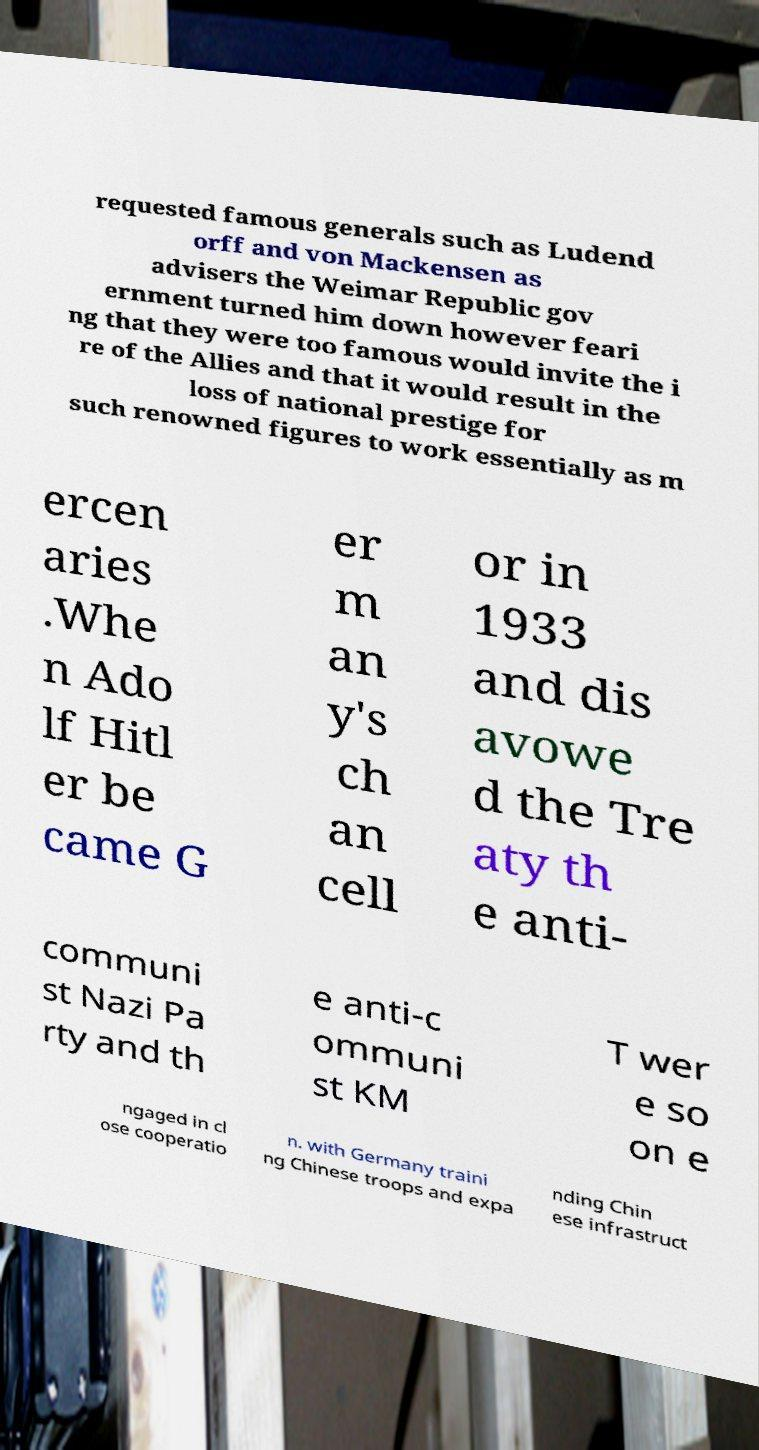Can you accurately transcribe the text from the provided image for me? requested famous generals such as Ludend orff and von Mackensen as advisers the Weimar Republic gov ernment turned him down however feari ng that they were too famous would invite the i re of the Allies and that it would result in the loss of national prestige for such renowned figures to work essentially as m ercen aries .Whe n Ado lf Hitl er be came G er m an y's ch an cell or in 1933 and dis avowe d the Tre aty th e anti- communi st Nazi Pa rty and th e anti-c ommuni st KM T wer e so on e ngaged in cl ose cooperatio n. with Germany traini ng Chinese troops and expa nding Chin ese infrastruct 